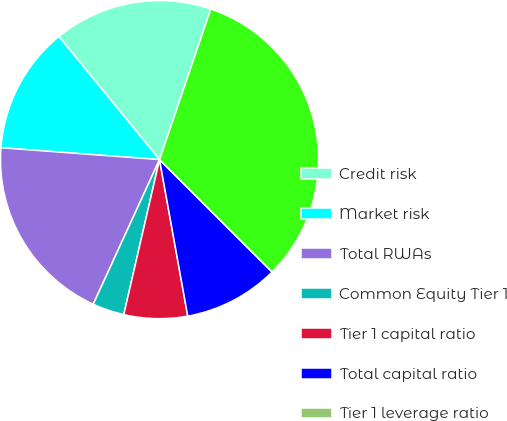Convert chart. <chart><loc_0><loc_0><loc_500><loc_500><pie_chart><fcel>Credit risk<fcel>Market risk<fcel>Total RWAs<fcel>Common Equity Tier 1<fcel>Tier 1 capital ratio<fcel>Total capital ratio<fcel>Tier 1 leverage ratio<fcel>Adjusted average assets<nl><fcel>16.13%<fcel>12.9%<fcel>19.35%<fcel>3.23%<fcel>6.45%<fcel>9.68%<fcel>0.0%<fcel>32.26%<nl></chart> 